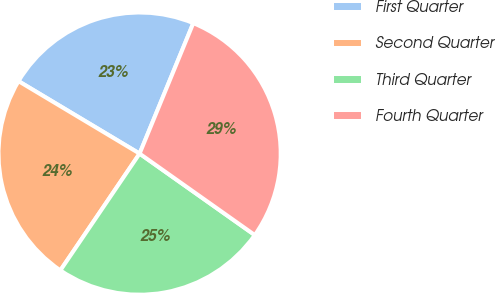Convert chart to OTSL. <chart><loc_0><loc_0><loc_500><loc_500><pie_chart><fcel>First Quarter<fcel>Second Quarter<fcel>Third Quarter<fcel>Fourth Quarter<nl><fcel>22.63%<fcel>24.09%<fcel>24.69%<fcel>28.58%<nl></chart> 